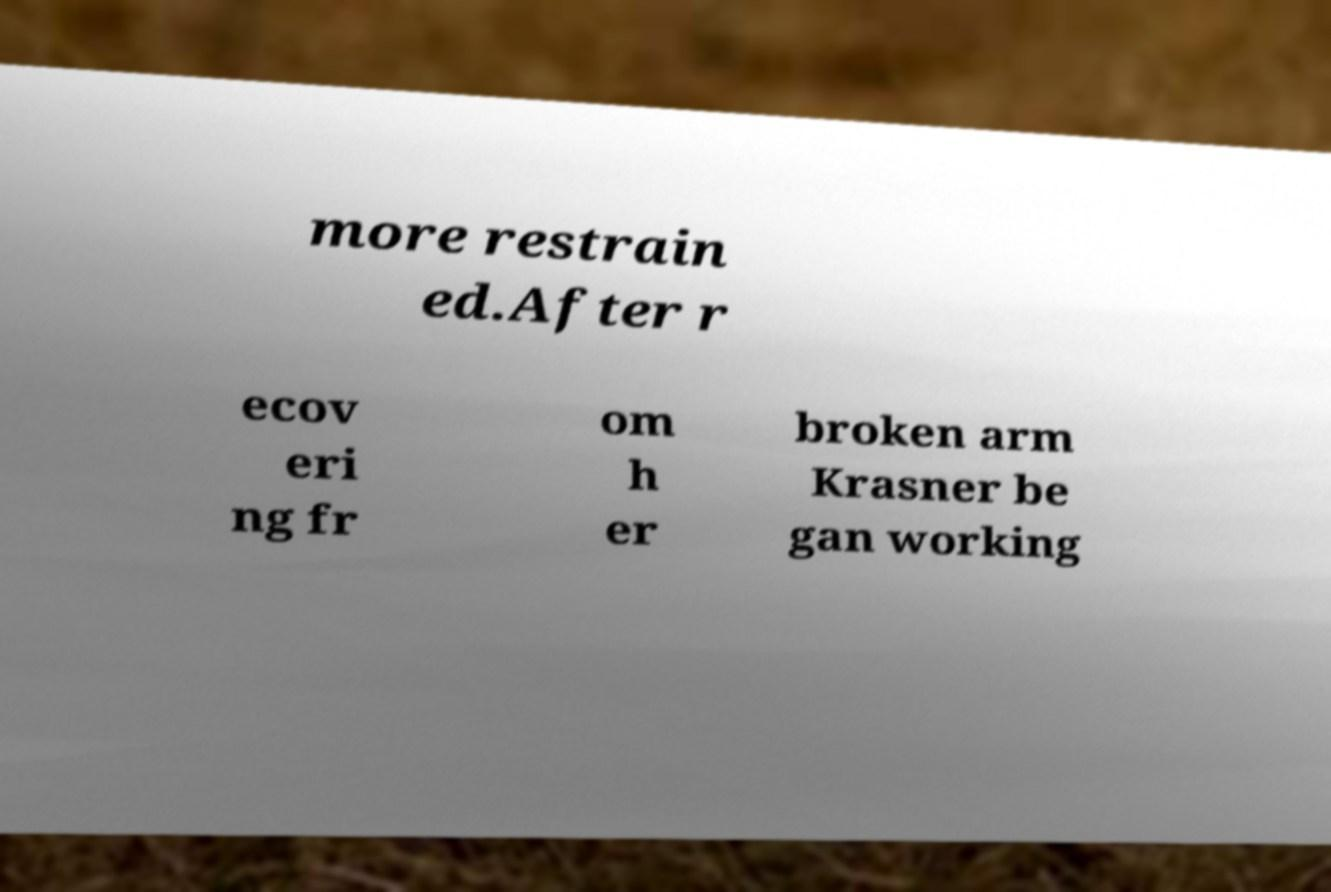Could you assist in decoding the text presented in this image and type it out clearly? more restrain ed.After r ecov eri ng fr om h er broken arm Krasner be gan working 